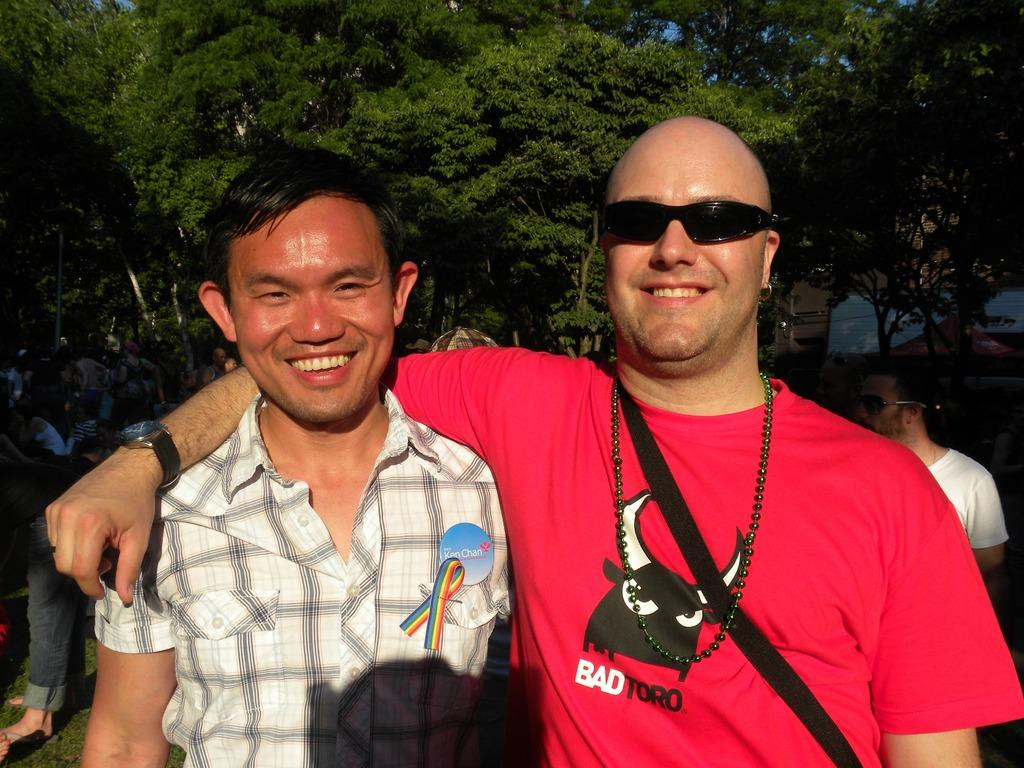How many men are visible in the image? There are two men standing in the image. What are the men doing in the image? The men are smiling and giving a pose for the picture. Can you describe the background of the image? There are more people and many trees in the background of the image. What type of story is the yak telling in the image? There is no yak present in the image, so it is not possible to determine what story it might be telling. 